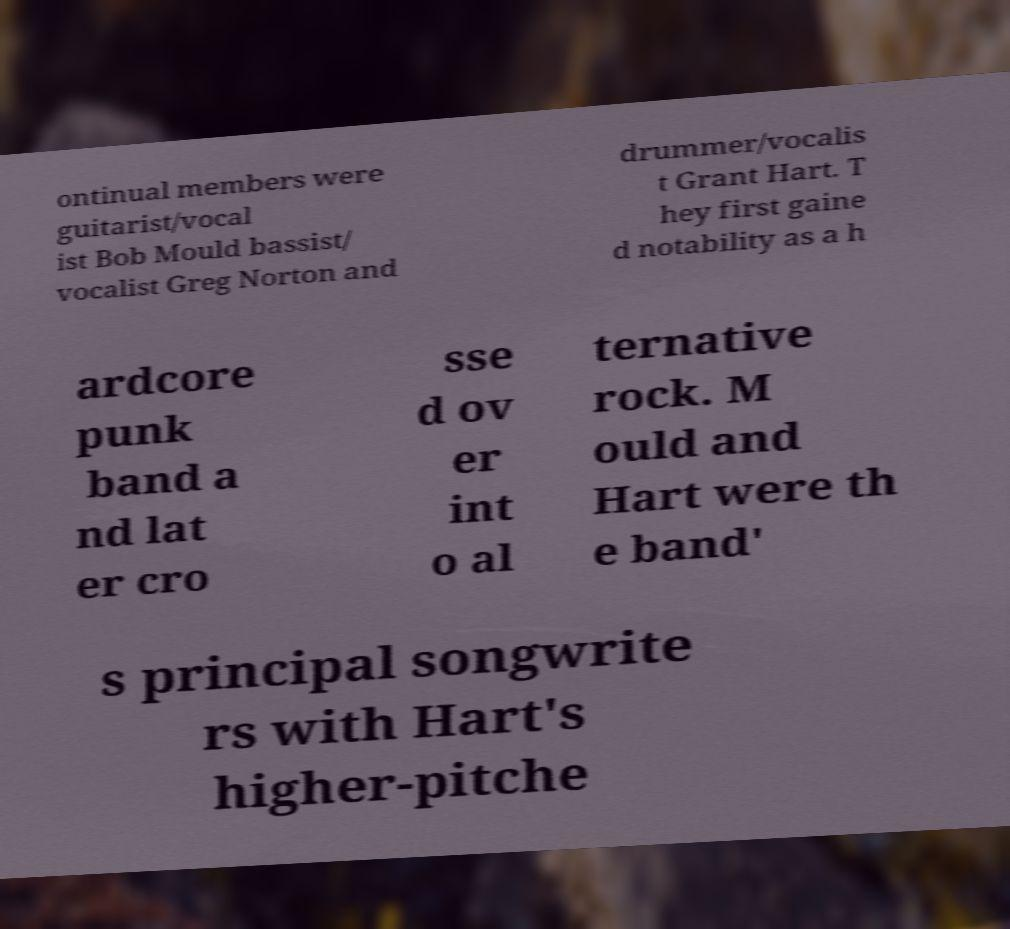Please identify and transcribe the text found in this image. ontinual members were guitarist/vocal ist Bob Mould bassist/ vocalist Greg Norton and drummer/vocalis t Grant Hart. T hey first gaine d notability as a h ardcore punk band a nd lat er cro sse d ov er int o al ternative rock. M ould and Hart were th e band' s principal songwrite rs with Hart's higher-pitche 